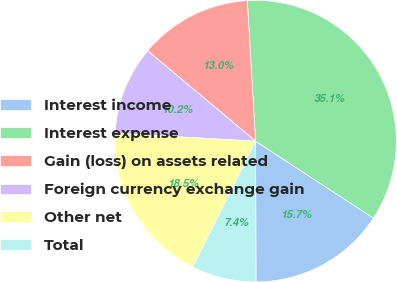<chart> <loc_0><loc_0><loc_500><loc_500><pie_chart><fcel>Interest income<fcel>Interest expense<fcel>Gain (loss) on assets related<fcel>Foreign currency exchange gain<fcel>Other net<fcel>Total<nl><fcel>15.74%<fcel>35.14%<fcel>12.97%<fcel>10.2%<fcel>18.51%<fcel>7.43%<nl></chart> 